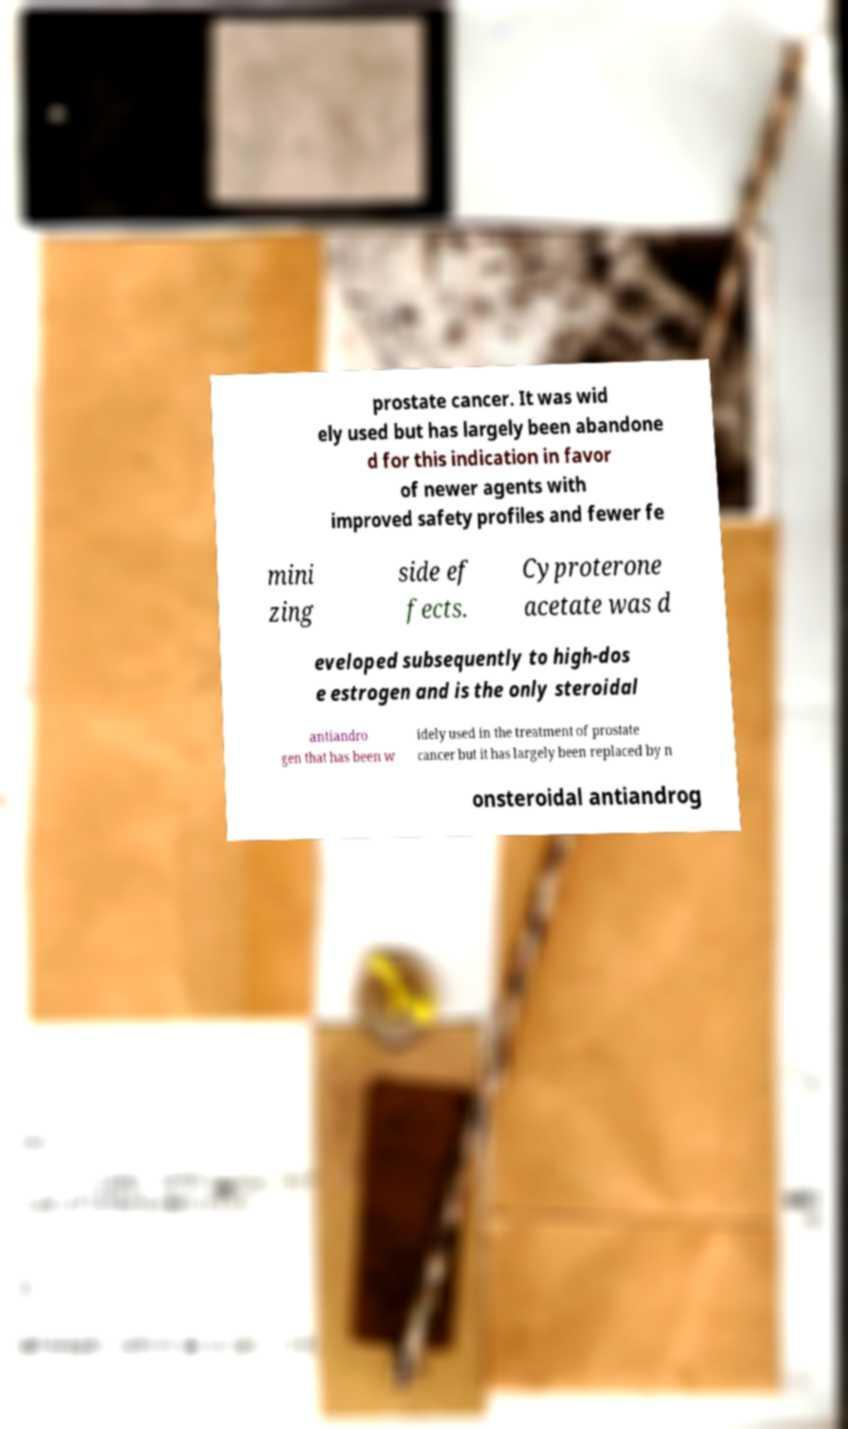What messages or text are displayed in this image? I need them in a readable, typed format. prostate cancer. It was wid ely used but has largely been abandone d for this indication in favor of newer agents with improved safety profiles and fewer fe mini zing side ef fects. Cyproterone acetate was d eveloped subsequently to high-dos e estrogen and is the only steroidal antiandro gen that has been w idely used in the treatment of prostate cancer but it has largely been replaced by n onsteroidal antiandrog 